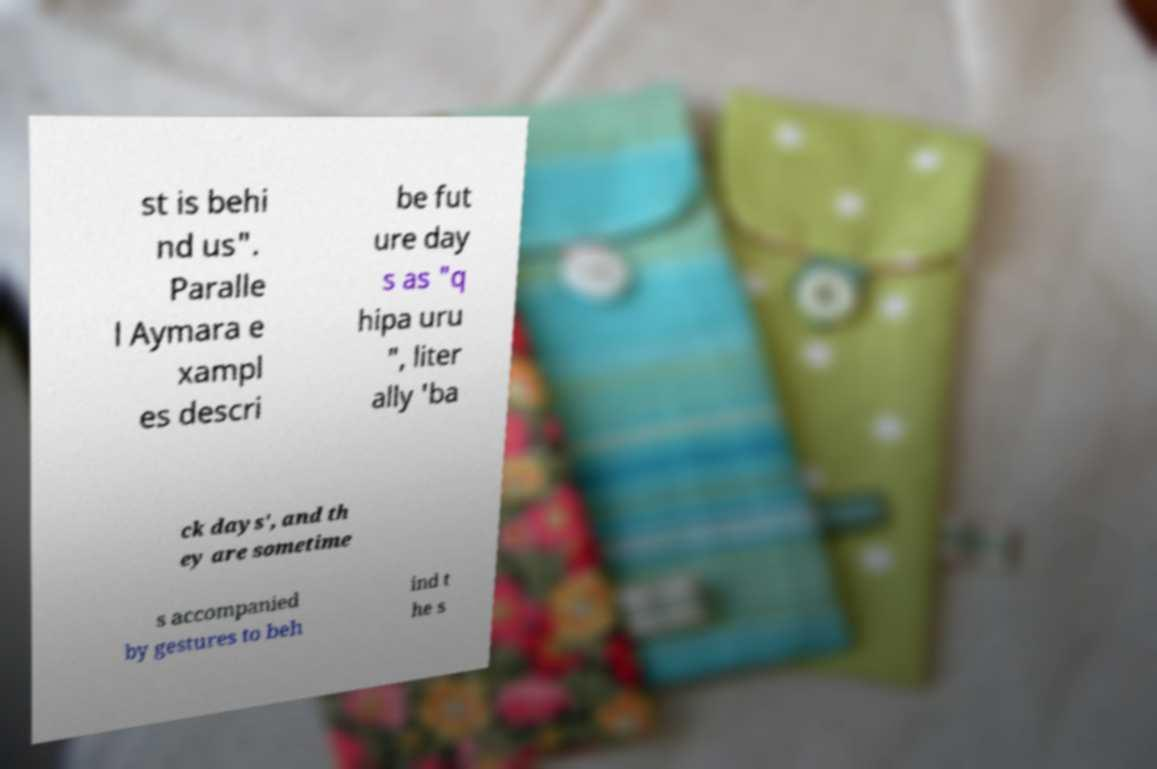Please read and relay the text visible in this image. What does it say? st is behi nd us". Paralle l Aymara e xampl es descri be fut ure day s as "q hipa uru ", liter ally 'ba ck days', and th ey are sometime s accompanied by gestures to beh ind t he s 